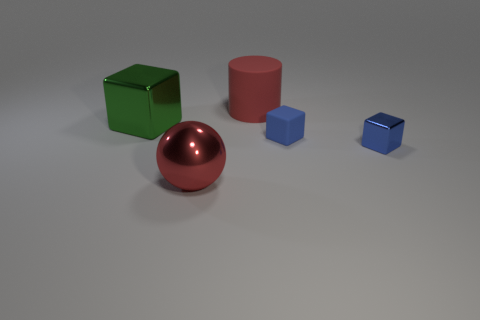Do the objects have any realistic textures or indications of a specific material? The objects have simplistic but realistic textures that simulate materials you might find in real life, such as shiny metal for the sphere and matte paint for the cubes and cylinder. They seem designed to reflect light differently, possibly to demonstrate lighting and shading in a three-dimensional environment. 